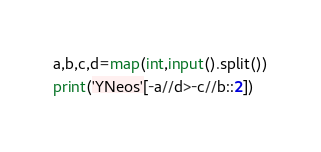Convert code to text. <code><loc_0><loc_0><loc_500><loc_500><_Python_>a,b,c,d=map(int,input().split())
print('YNeos'[-a//d>-c//b::2])</code> 